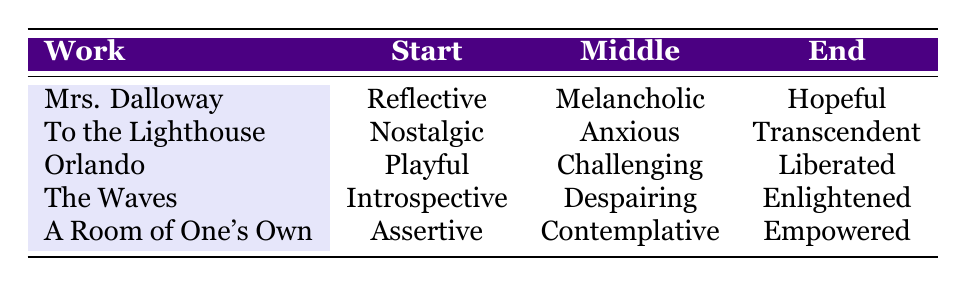What is the emotional tone at the start of "The Waves"? Referring to the table, under "The Waves," the emotional tone at the start is listed as "Introspective."
Answer: Introspective Which work has a hopeful tone at the end? In the table, "Mrs. Dalloway" shows a "Hopeful" emotional tone at the end.
Answer: Mrs. Dalloway Is the middle emotional tone for "Orlando" more playful or anxious? Looking at the table, the middle emotional tone for "Orlando" is "Challenging," which is not "Playful" or "Anxious." So the answer is no.
Answer: No Which work transitions from an assertive start to an empowered end? By examining the table, "A Room of One's Own" has an "Assertive" tone at the start and "Empowered" tone at the end, indicating it fits this description.
Answer: A Room of One's Own What is the difference between the start tone of "Mrs. Dalloway" and "To the Lighthouse"? The emotional tone at the start of "Mrs. Dalloway" is "Reflective," and for "To the Lighthouse," it is "Nostalgic." The difference is that they represent different emotional orientations, not a numerical difference. Thus, it's not quantifiable.
Answer: Not applicable Which work has a middle tone that is either melancholic or contemplative? The table shows "Mrs. Dalloway" has a middle tone of "Melancholic," and "A Room of One's Own" has "Contemplative," so both works fit this description.
Answer: Yes What is the emotional tone at the end of "Orlando"? According to the table, "Orlando" ends with an emotional tone of "Liberated."
Answer: Liberated Is there a work that has a middle emotional tone of despairing? Referring to the table, "The Waves" has a middle tone of "Despairing." Therefore, the answer is affirmative.
Answer: Yes Which work shows a shift from anxious in the middle to transcendent at the end? The table indicates that "To the Lighthouse" has an "Anxious" middle tone and transitions to a "Transcendent" end tone, fitting this description.
Answer: To the Lighthouse 